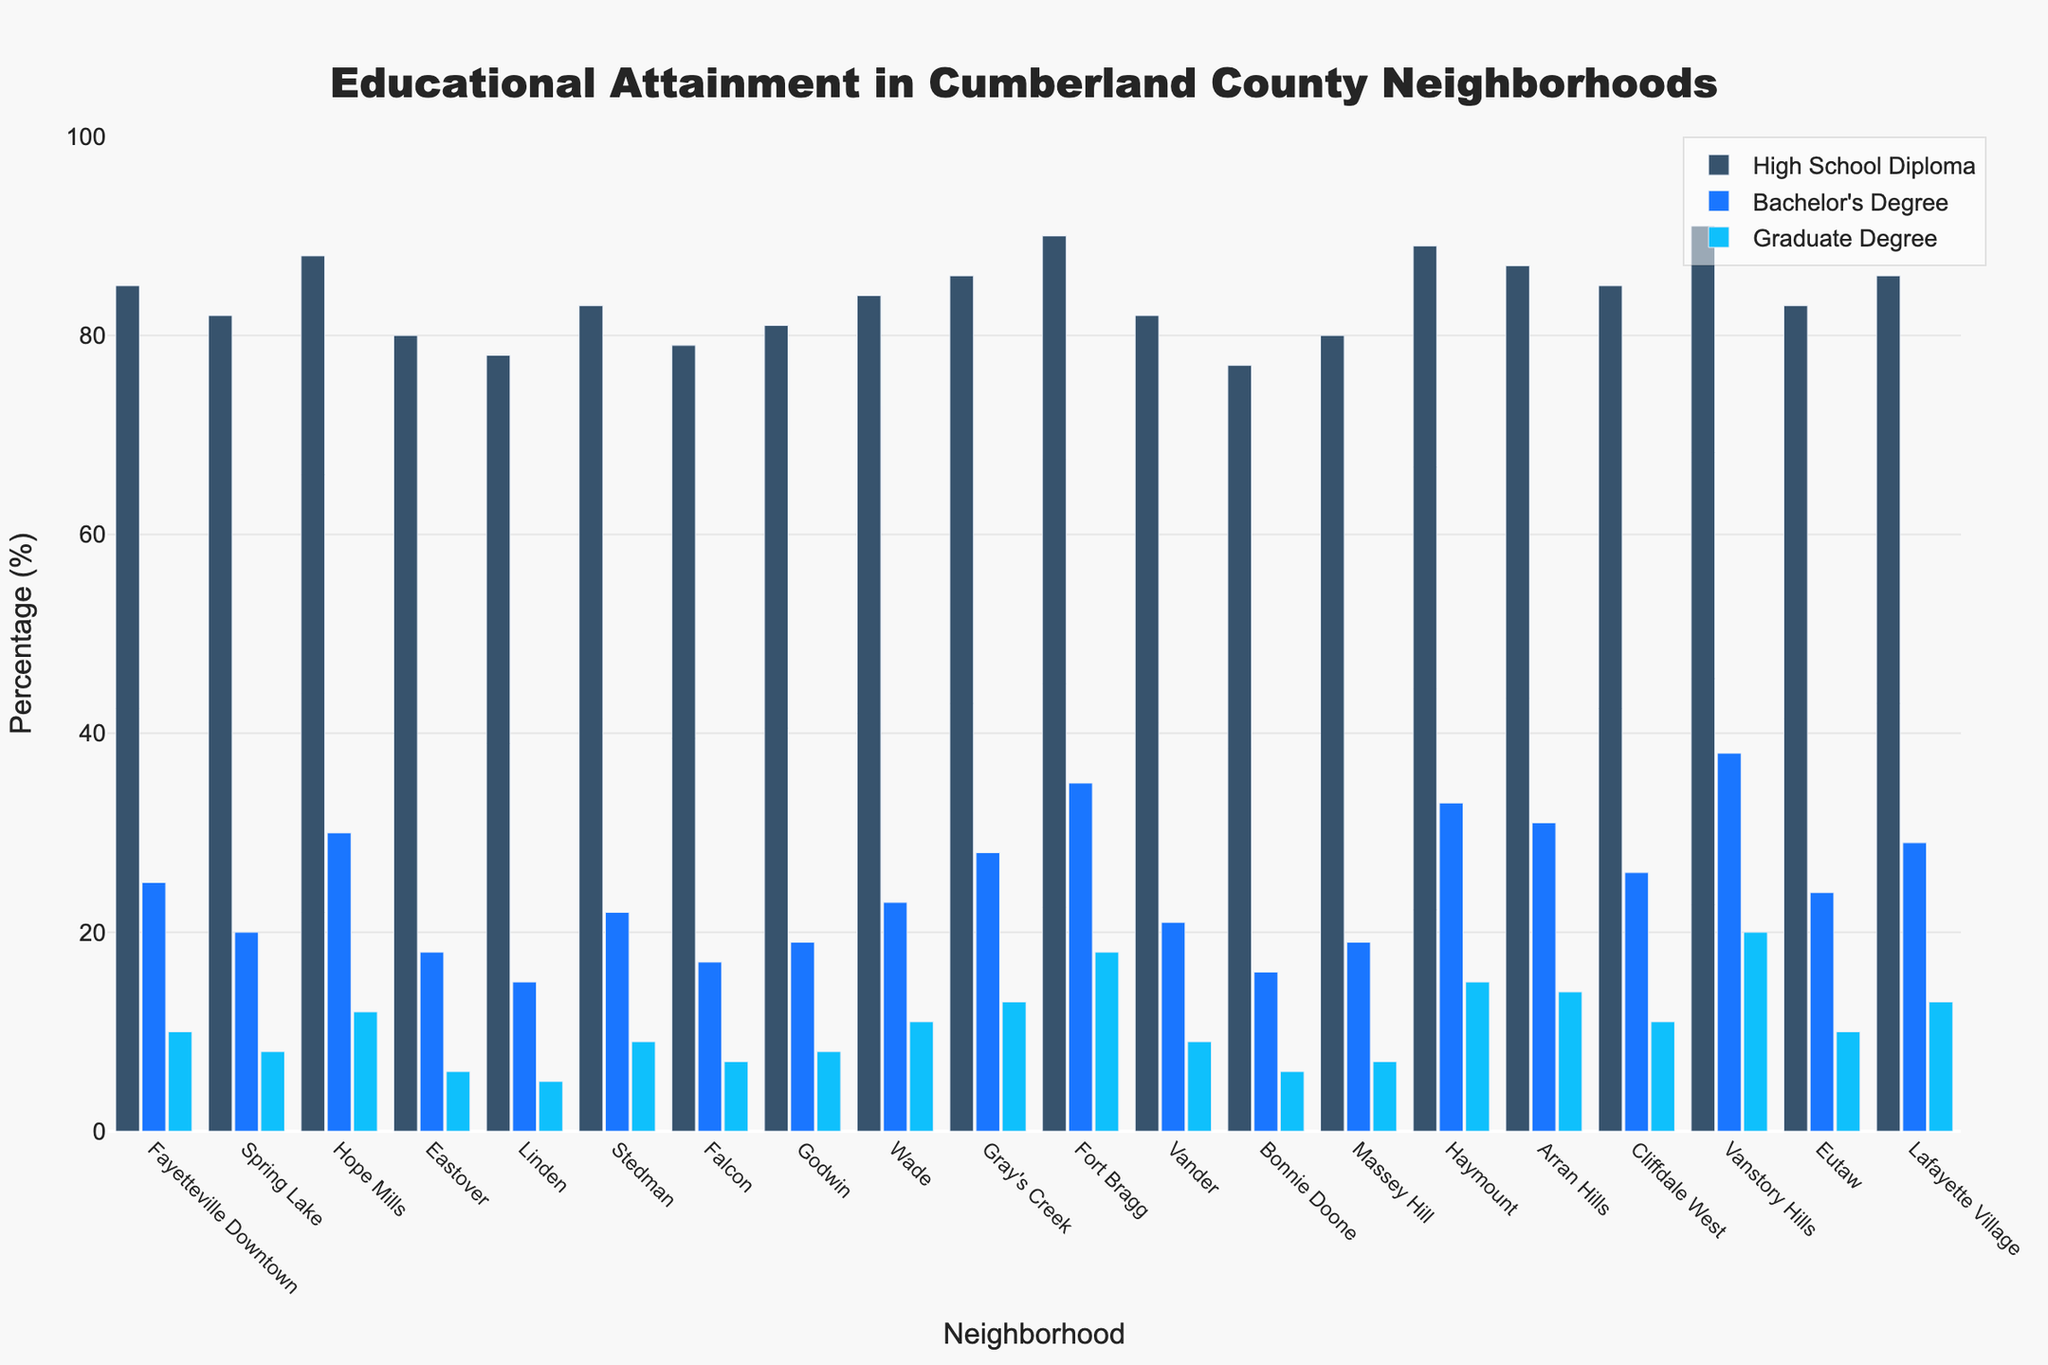Which neighborhood has the highest percentage of residents with a Bachelor's Degree? Vanstory Hills has the highest bar for Bachelor's Degree, indicating it has the highest percentage of residents with a Bachelor's Degree.
Answer: Vanstory Hills Which neighborhood has the lowest percentage of residents with a High School Diploma? The shortest bar for High School Diploma is for Bonnie Doone, indicating it has the lowest percentage of residents with a High School Diploma.
Answer: Bonnie Doone How does the percentage of residents with a Graduate Degree in Haymount compare to that in Fort Bragg? The bar for Graduate Degree in Fort Bragg is taller than the one in Haymount, indicating a higher percentage in Fort Bragg than in Haymount.
Answer: Fort Bragg has a higher percentage Which neighborhoods have exactly equal percentages of High School Diploma holders? Using the visual representation, both Fayetteville Downtown and Cliffdale West have bars of equal height for High School Diploma.
Answer: Fayetteville Downtown, Cliffdale West What is the average percentage of Bachelor’s Degree holders in Godwin, Wade, and Falcon? The percentages for Bachelor’s Degree holders are 19% (Godwin), 23% (Wade), and 17% (Falcon). The sum is 59%, and the average is 59 / 3 = 19.67%.
Answer: 19.67% Is there any neighborhood where the percentage of Bachelor's Degree holders exceeds the percentage of High School Diploma holders? All bars representing Bachelor's Degrees are shorter than those representing High School Diplomas for all neighborhoods, so no neighborhood exceeds.
Answer: No In which neighborhood is the difference between the percentages of High School Diploma and Graduate Degree holders the greatest? Vanstory Hills has 91% (High School Diploma) and 20% (Graduate Degree), giving a difference of 71%, which appears to be the largest.
Answer: Vanstory Hills What is the combined percentage of High School Diploma and Graduate Degree holders in Fort Bragg? Fort Bragg has 90% (High School Diploma) and 18% (Graduate Degree). The combined percentage is 90 + 18 = 108%.
Answer: 108% Which neighborhood has the second-highest percentage of residents with a Bachelor's Degree? Haymount is second only to Vanstory Hills in the height of the bar representing Bachelor's Degree.
Answer: Haymount Considering the neighborhoods with the highest percentages of High School Diplomas, Bachelor's Degrees, and Graduate Degrees, which neighborhoods are top in each category? Vanstory Hills tops Bachelor's Degrees (38%) and Graduate Degrees (20%), while Vanstory Hills also has the highest High School Diplomas (91%).
Answer: Vanstory Hills 